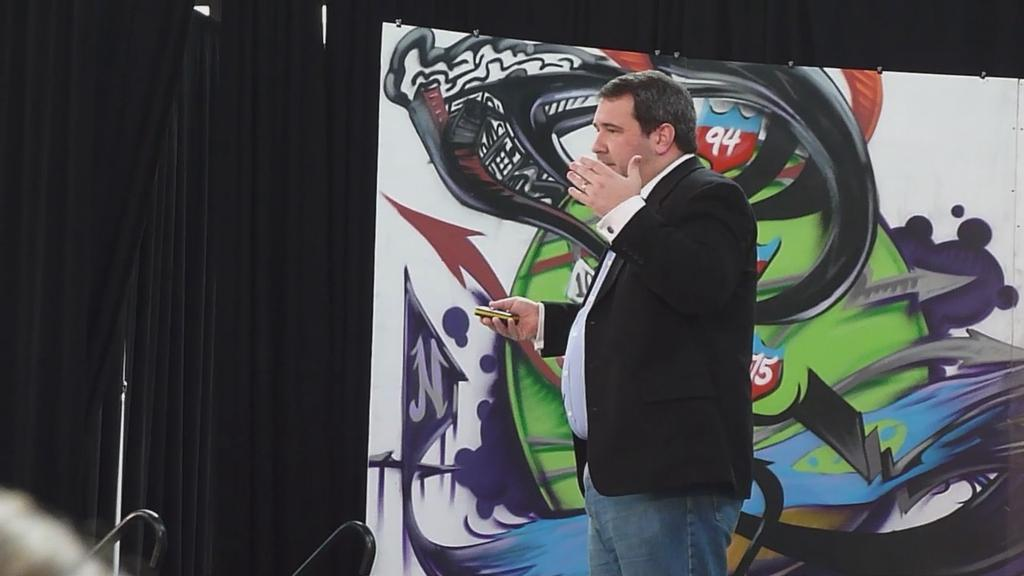What is the main subject of the image? There is a man standing in the image. Where is the man located in the image? The man is on the right side of the image. What is the man wearing in the image? The man is wearing a black coat. What can be seen on the wall in the image? There is a painting on the wall in the image. What type of plot is the man planning to use in the image? There is no indication in the image that the man is planning to use a plot for any purpose. 